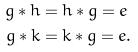Convert formula to latex. <formula><loc_0><loc_0><loc_500><loc_500>g \ast h & = h \ast g = e \\ g \ast k & = k \ast g = e .</formula> 